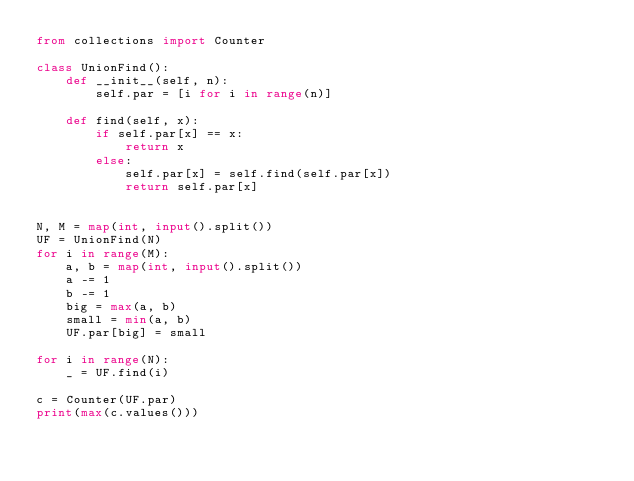Convert code to text. <code><loc_0><loc_0><loc_500><loc_500><_Python_>from collections import Counter

class UnionFind():
    def __init__(self, n):
        self.par = [i for i in range(n)]
        
    def find(self, x):
        if self.par[x] == x:
            return x
        else:
            self.par[x] = self.find(self.par[x])
            return self.par[x]
            

N, M = map(int, input().split())
UF = UnionFind(N)
for i in range(M):
    a, b = map(int, input().split())
    a -= 1
    b -= 1
    big = max(a, b)
    small = min(a, b)
    UF.par[big] = small
    
for i in range(N):
    _ = UF.find(i)

c = Counter(UF.par)
print(max(c.values()))</code> 